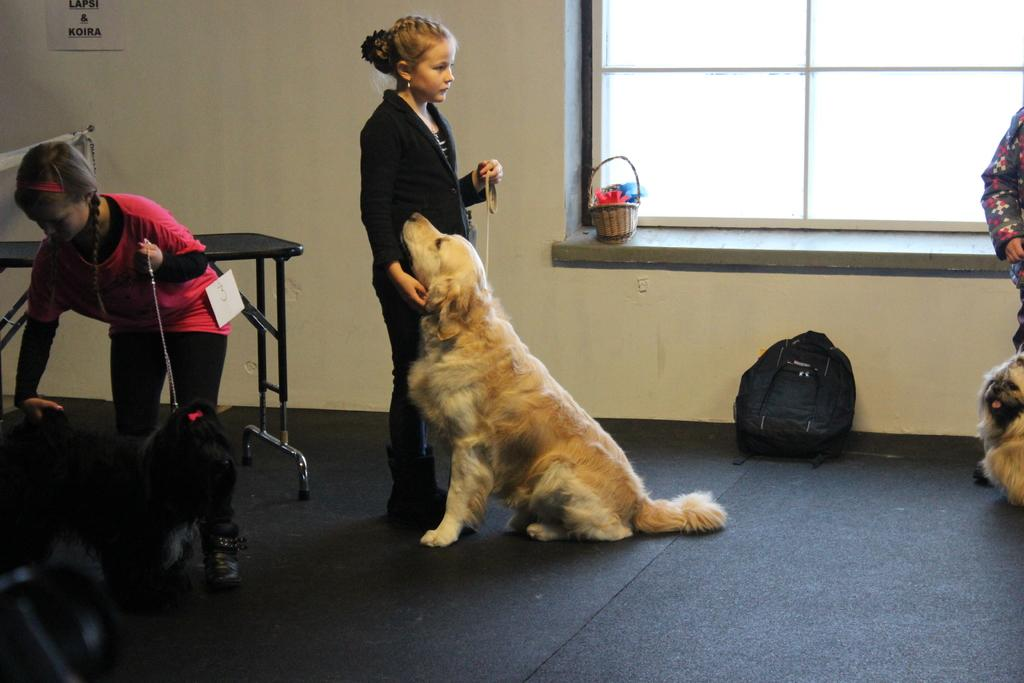How many children are present in the image? There are three children in the image. What are the children doing in the image? The children are standing on the floor and holding dogs. What other objects can be seen in the image? There is a table, a bag, a paper on a wall, and a basket beside a window in the image. What type of glass is being used to transport the statement in the image? There is no glass, transport, or statement present in the image. 